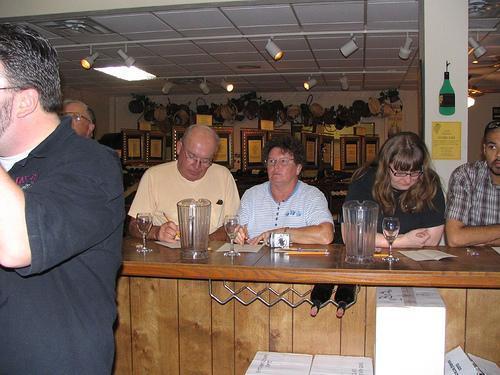How many people are at the bar?
Give a very brief answer. 5. How many people are looking down?
Give a very brief answer. 2. How many people can you see?
Give a very brief answer. 5. 